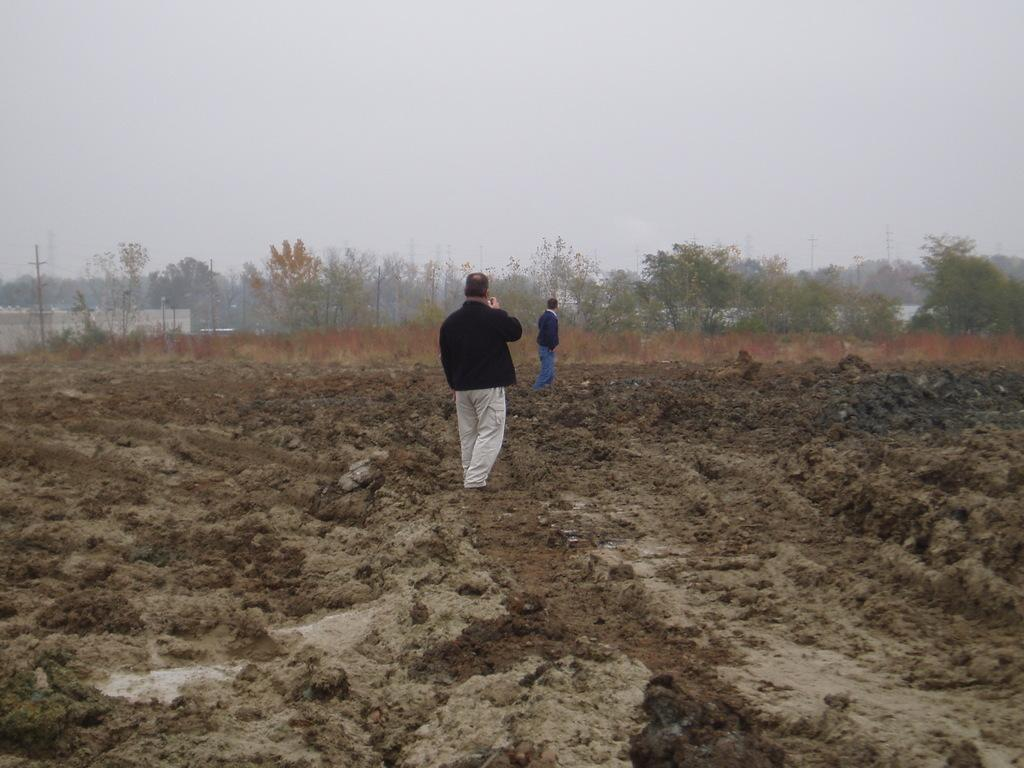How many people are in the image? There are two people standing in the image. What is the surface on which the people are standing? The people are standing on mud. What can be seen in the background of the image? There are trees, buildings, utility poles, and the sky visible in the background of the image. What type of collar is the spy wearing in the image? There is no spy or collar present in the image. 